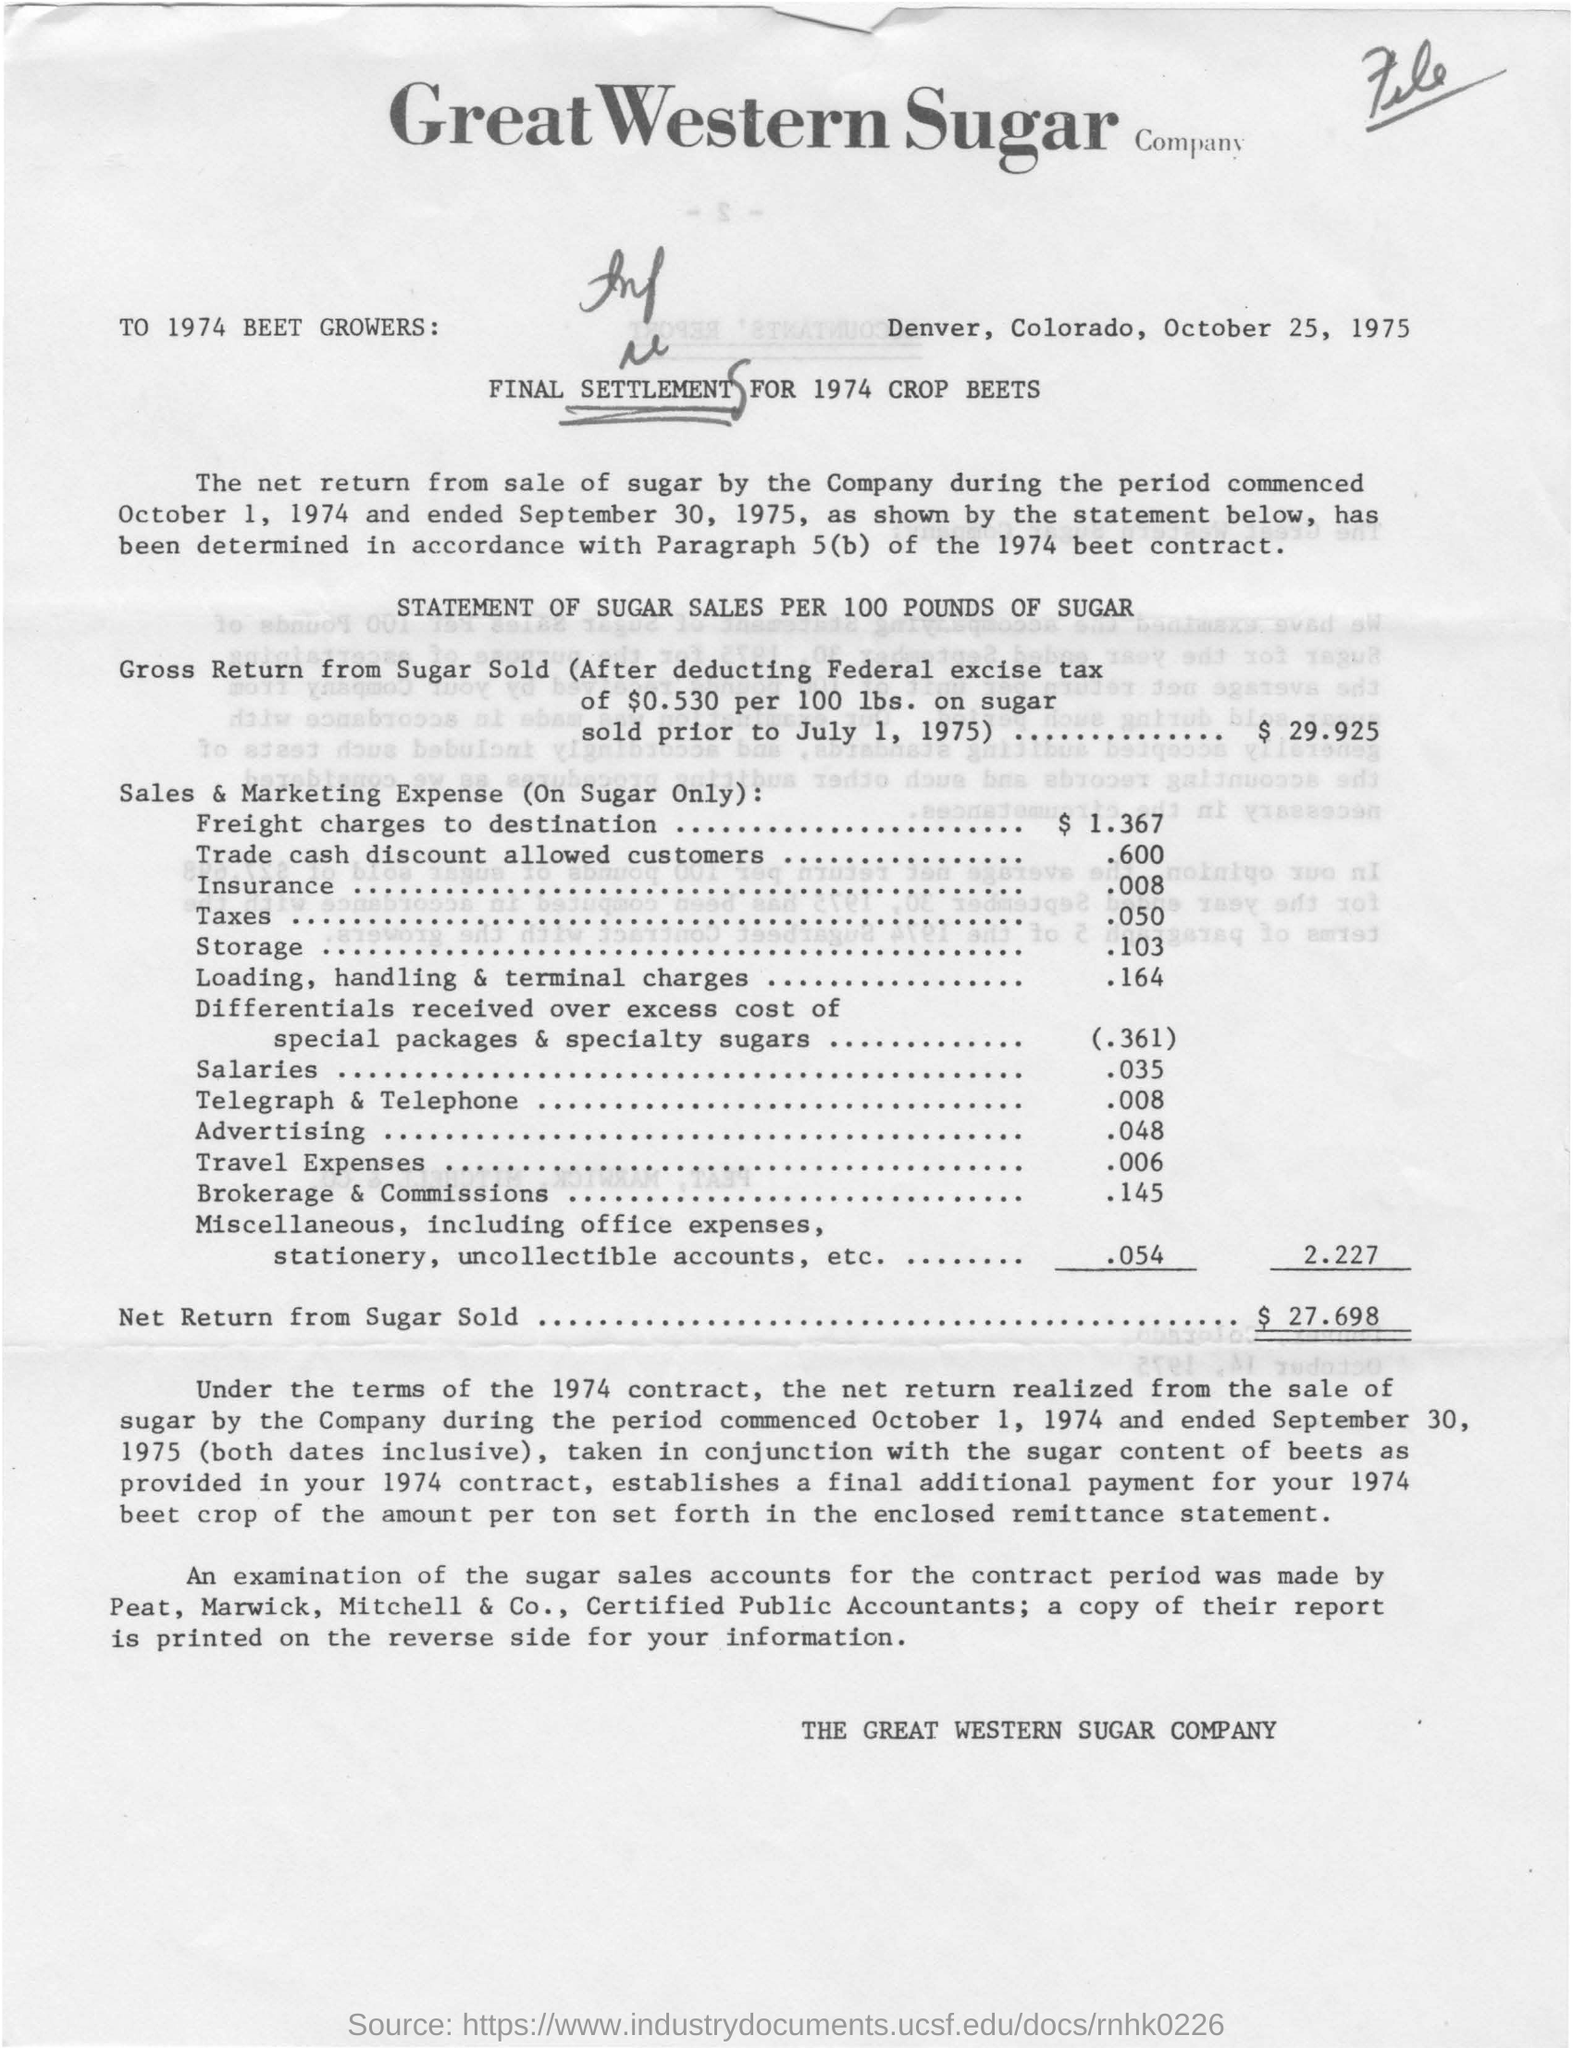When is the document dated?
Ensure brevity in your answer.  October 25, 1975. What is the amount of Gross Return from Sugar Sold?
Your answer should be compact. $ 29.925. Which company's name is mentioned?
Your answer should be very brief. Great Western Sugar Company. What is the statement about?
Give a very brief answer. STATEMENT OF SUGAR SALES PER 100 POUNDS OF SUGAR. 